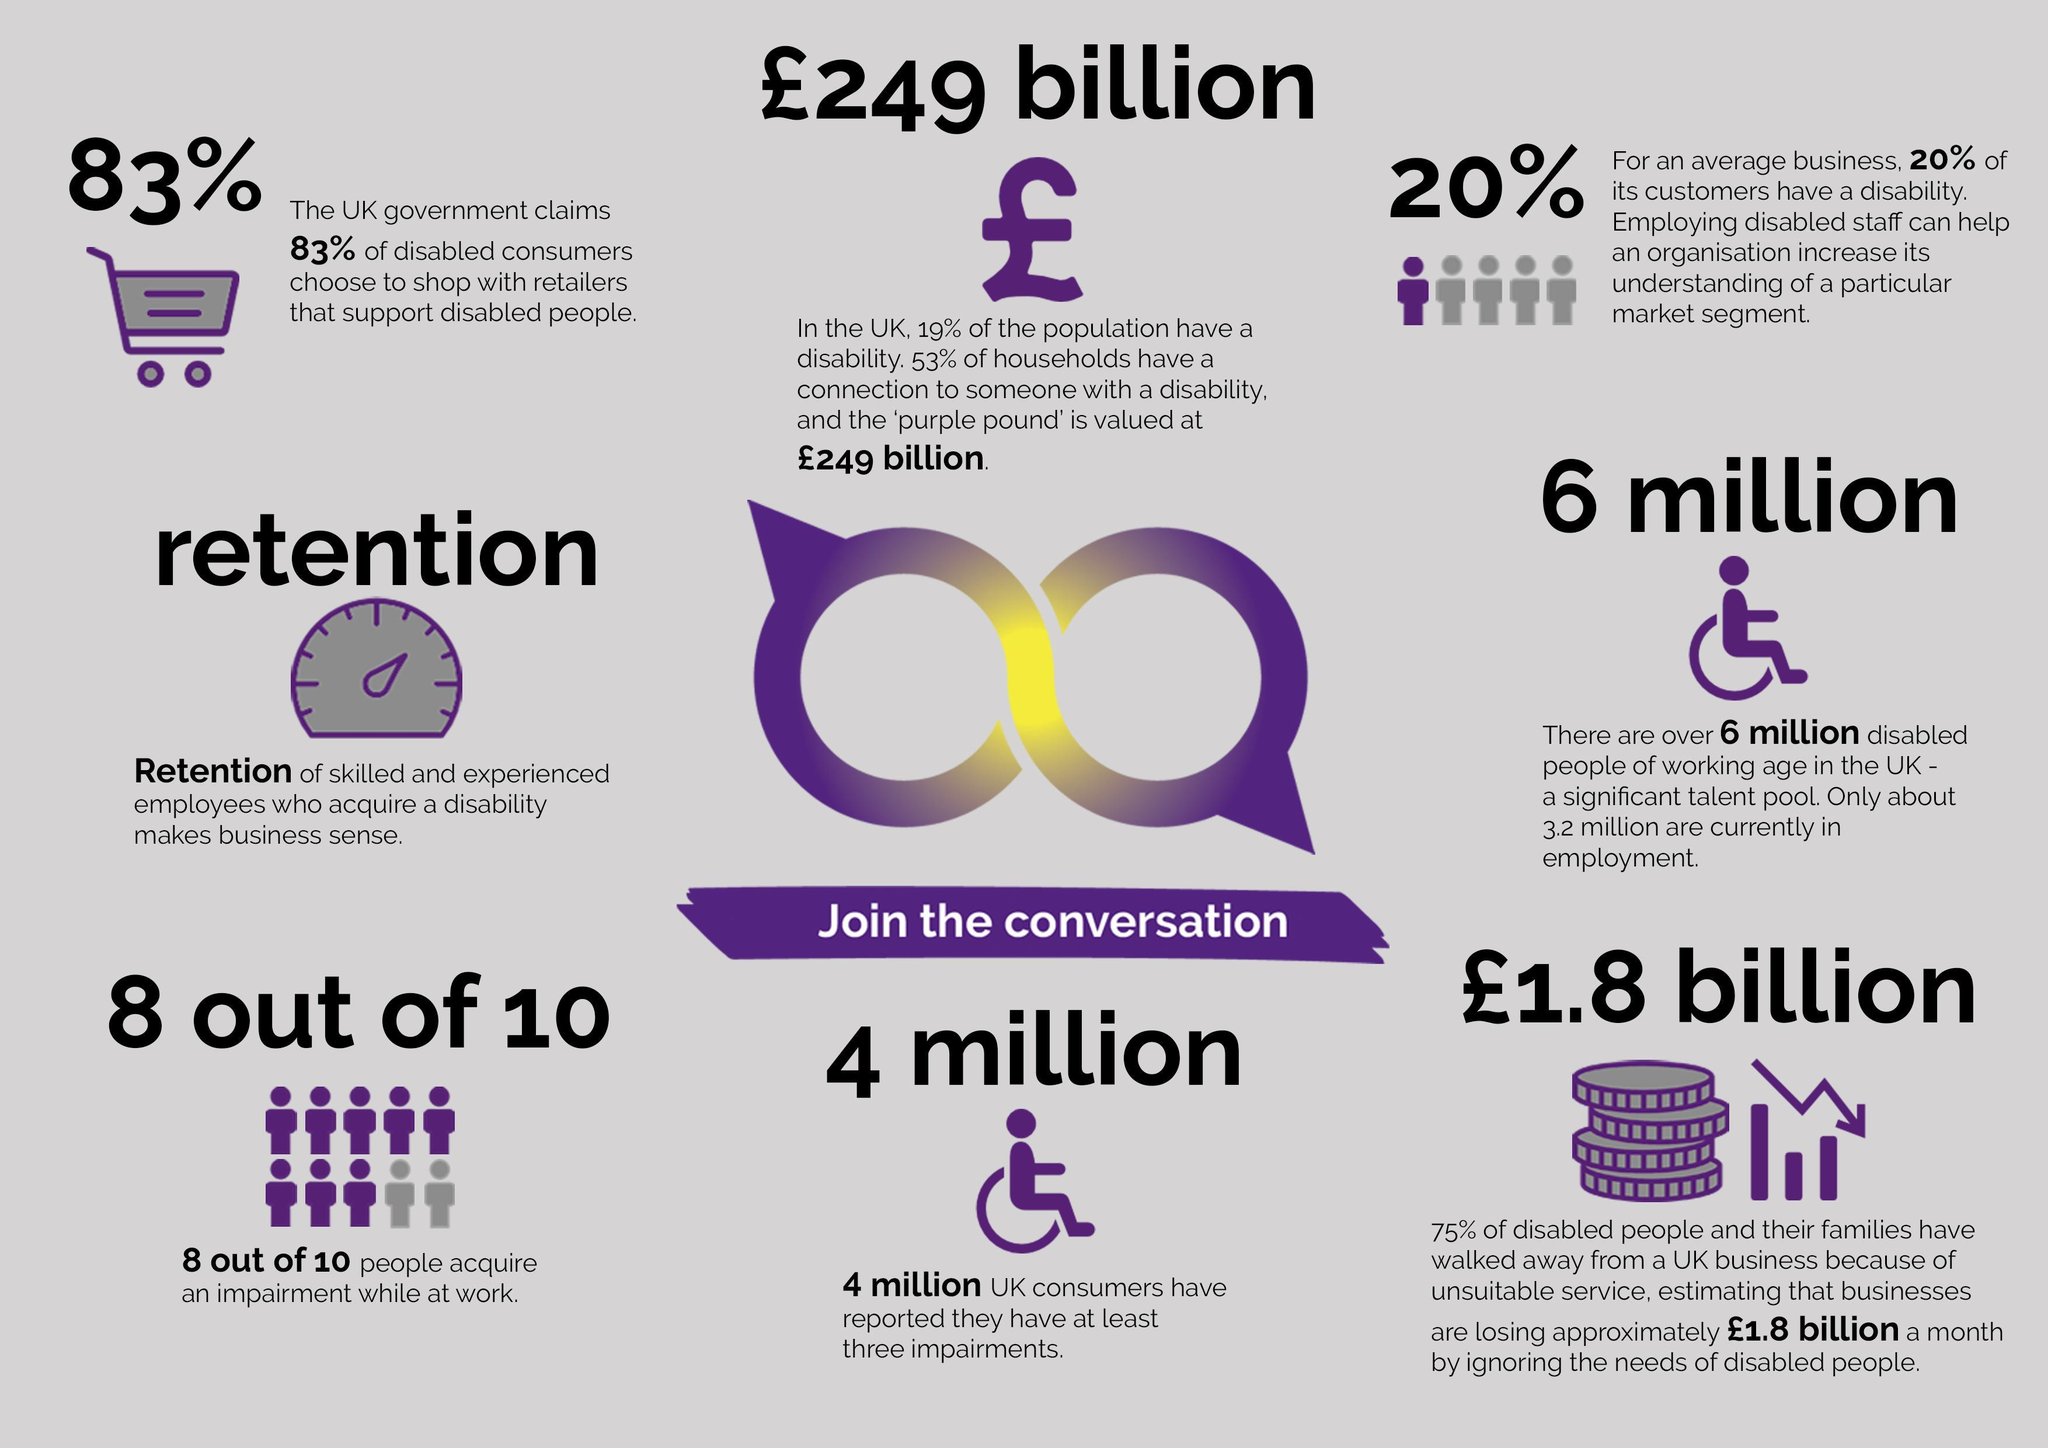What is the number of unemployed people with disability in the UK?
Answer the question with a short phrase. 2.4 million 